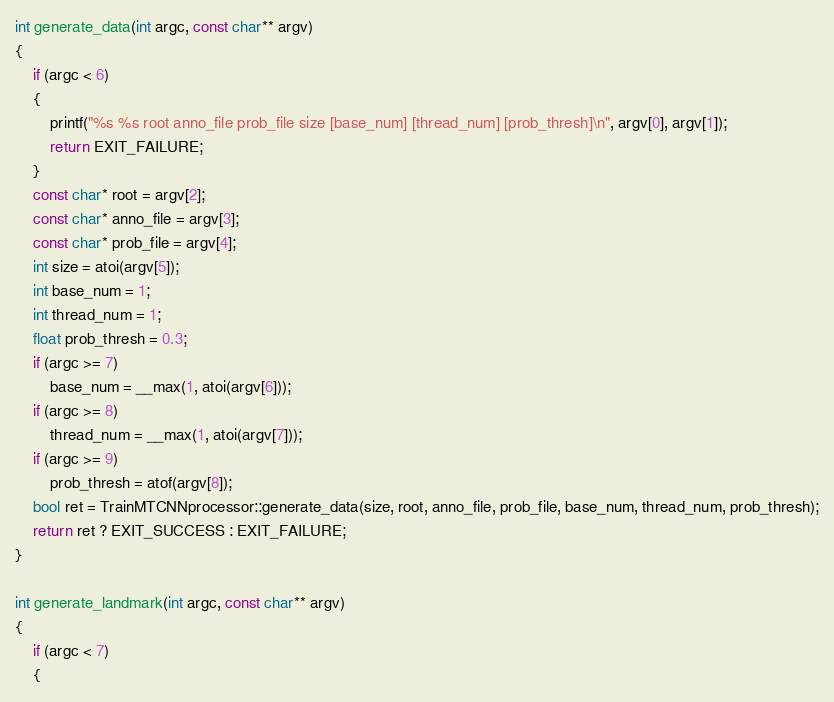Convert code to text. <code><loc_0><loc_0><loc_500><loc_500><_C++_>int generate_data(int argc, const char** argv)
{
	if (argc < 6)
	{
		printf("%s %s root anno_file prob_file size [base_num] [thread_num] [prob_thresh]\n", argv[0], argv[1]);
		return EXIT_FAILURE;
	}
	const char* root = argv[2];
	const char* anno_file = argv[3];
	const char* prob_file = argv[4];
	int size = atoi(argv[5]);
	int base_num = 1;
	int thread_num = 1;
	float prob_thresh = 0.3;
	if (argc >= 7)
		base_num = __max(1, atoi(argv[6]));
	if (argc >= 8)
		thread_num = __max(1, atoi(argv[7]));
	if (argc >= 9)
		prob_thresh = atof(argv[8]);
	bool ret = TrainMTCNNprocessor::generate_data(size, root, anno_file, prob_file, base_num, thread_num, prob_thresh);
	return ret ? EXIT_SUCCESS : EXIT_FAILURE;
}

int generate_landmark(int argc, const char** argv)
{
	if (argc < 7)
	{</code> 